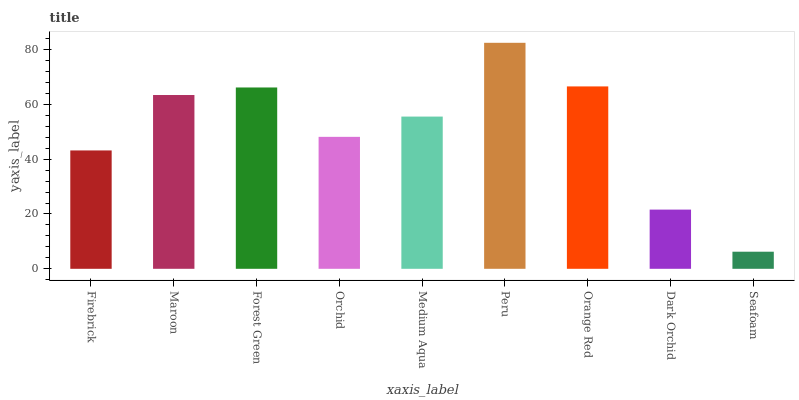Is Seafoam the minimum?
Answer yes or no. Yes. Is Peru the maximum?
Answer yes or no. Yes. Is Maroon the minimum?
Answer yes or no. No. Is Maroon the maximum?
Answer yes or no. No. Is Maroon greater than Firebrick?
Answer yes or no. Yes. Is Firebrick less than Maroon?
Answer yes or no. Yes. Is Firebrick greater than Maroon?
Answer yes or no. No. Is Maroon less than Firebrick?
Answer yes or no. No. Is Medium Aqua the high median?
Answer yes or no. Yes. Is Medium Aqua the low median?
Answer yes or no. Yes. Is Orange Red the high median?
Answer yes or no. No. Is Orchid the low median?
Answer yes or no. No. 